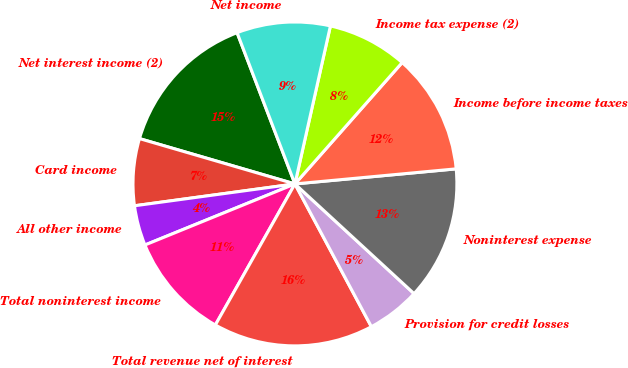Convert chart to OTSL. <chart><loc_0><loc_0><loc_500><loc_500><pie_chart><fcel>Net interest income (2)<fcel>Card income<fcel>All other income<fcel>Total noninterest income<fcel>Total revenue net of interest<fcel>Provision for credit losses<fcel>Noninterest expense<fcel>Income before income taxes<fcel>Income tax expense (2)<fcel>Net income<nl><fcel>14.67%<fcel>6.67%<fcel>4.0%<fcel>10.67%<fcel>16.0%<fcel>5.33%<fcel>13.33%<fcel>12.0%<fcel>8.0%<fcel>9.33%<nl></chart> 